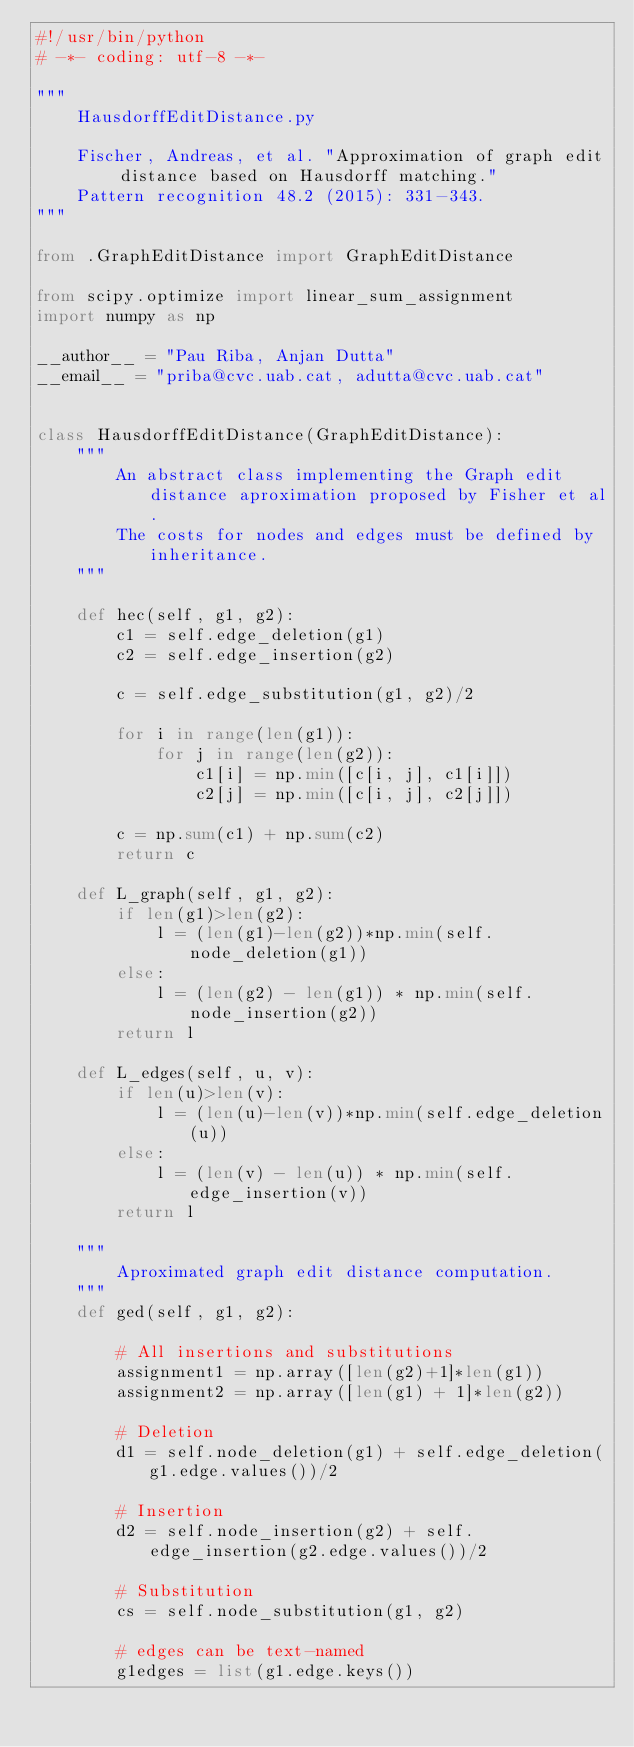Convert code to text. <code><loc_0><loc_0><loc_500><loc_500><_Python_>#!/usr/bin/python
# -*- coding: utf-8 -*-

"""
    HausdorffEditDistance.py

    Fischer, Andreas, et al. "Approximation of graph edit distance based on Hausdorff matching."
    Pattern recognition 48.2 (2015): 331-343.
"""

from .GraphEditDistance import GraphEditDistance

from scipy.optimize import linear_sum_assignment
import numpy as np

__author__ = "Pau Riba, Anjan Dutta"
__email__ = "priba@cvc.uab.cat, adutta@cvc.uab.cat"


class HausdorffEditDistance(GraphEditDistance):
    """
        An abstract class implementing the Graph edit distance aproximation proposed by Fisher et al.
        The costs for nodes and edges must be defined by inheritance.
    """

    def hec(self, g1, g2):
        c1 = self.edge_deletion(g1)
        c2 = self.edge_insertion(g2)

        c = self.edge_substitution(g1, g2)/2

        for i in range(len(g1)):
            for j in range(len(g2)):
                c1[i] = np.min([c[i, j], c1[i]])
                c2[j] = np.min([c[i, j], c2[j]])

        c = np.sum(c1) + np.sum(c2)
        return c

    def L_graph(self, g1, g2):
        if len(g1)>len(g2):
            l = (len(g1)-len(g2))*np.min(self.node_deletion(g1))
        else:
            l = (len(g2) - len(g1)) * np.min(self.node_insertion(g2))
        return l

    def L_edges(self, u, v):
        if len(u)>len(v):
            l = (len(u)-len(v))*np.min(self.edge_deletion(u))
        else:
            l = (len(v) - len(u)) * np.min(self.edge_insertion(v))
        return l

    """
        Aproximated graph edit distance computation.
    """
    def ged(self, g1, g2):

        # All insertions and substitutions
        assignment1 = np.array([len(g2)+1]*len(g1))
        assignment2 = np.array([len(g1) + 1]*len(g2))

        # Deletion
        d1 = self.node_deletion(g1) + self.edge_deletion(g1.edge.values())/2

        # Insertion
        d2 = self.node_insertion(g2) + self.edge_insertion(g2.edge.values())/2

        # Substitution
        cs = self.node_substitution(g1, g2)

        # edges can be text-named
        g1edges = list(g1.edge.keys())</code> 